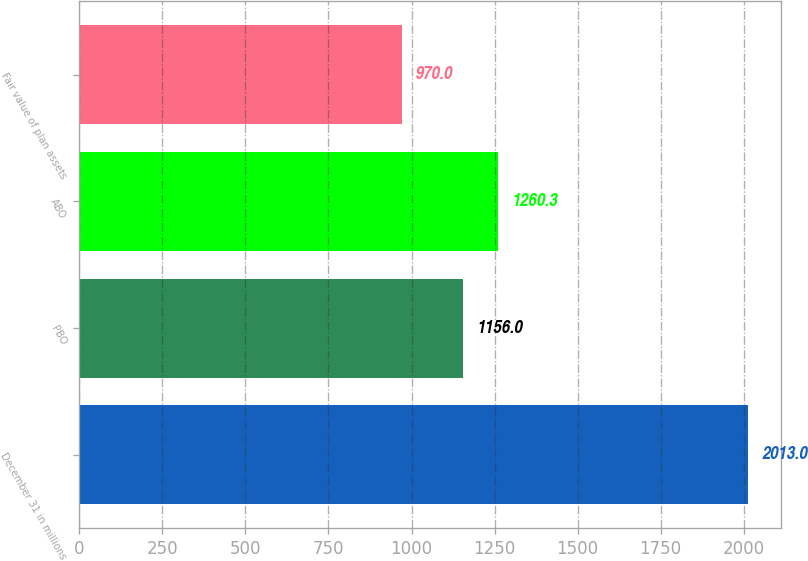Convert chart. <chart><loc_0><loc_0><loc_500><loc_500><bar_chart><fcel>December 31 in millions<fcel>PBO<fcel>ABO<fcel>Fair value of plan assets<nl><fcel>2013<fcel>1156<fcel>1260.3<fcel>970<nl></chart> 